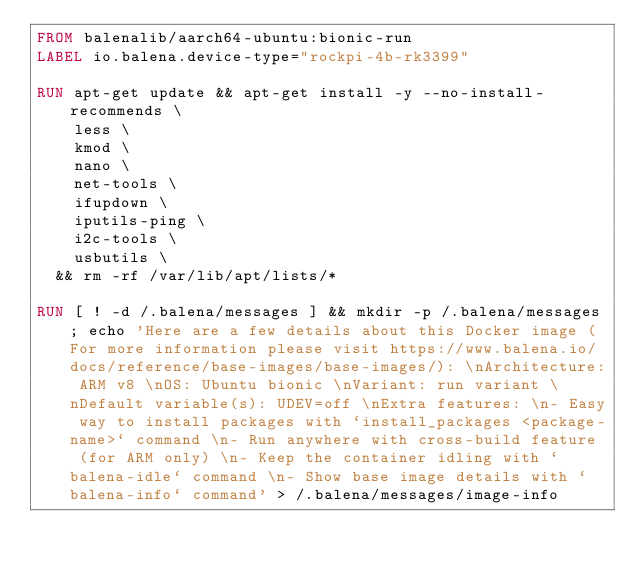<code> <loc_0><loc_0><loc_500><loc_500><_Dockerfile_>FROM balenalib/aarch64-ubuntu:bionic-run
LABEL io.balena.device-type="rockpi-4b-rk3399"

RUN apt-get update && apt-get install -y --no-install-recommends \
		less \
		kmod \
		nano \
		net-tools \
		ifupdown \
		iputils-ping \
		i2c-tools \
		usbutils \
	&& rm -rf /var/lib/apt/lists/*

RUN [ ! -d /.balena/messages ] && mkdir -p /.balena/messages; echo 'Here are a few details about this Docker image (For more information please visit https://www.balena.io/docs/reference/base-images/base-images/): \nArchitecture: ARM v8 \nOS: Ubuntu bionic \nVariant: run variant \nDefault variable(s): UDEV=off \nExtra features: \n- Easy way to install packages with `install_packages <package-name>` command \n- Run anywhere with cross-build feature  (for ARM only) \n- Keep the container idling with `balena-idle` command \n- Show base image details with `balena-info` command' > /.balena/messages/image-info</code> 